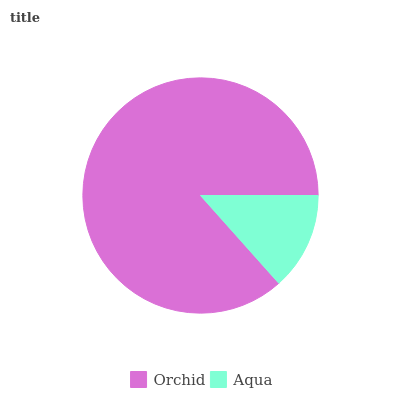Is Aqua the minimum?
Answer yes or no. Yes. Is Orchid the maximum?
Answer yes or no. Yes. Is Aqua the maximum?
Answer yes or no. No. Is Orchid greater than Aqua?
Answer yes or no. Yes. Is Aqua less than Orchid?
Answer yes or no. Yes. Is Aqua greater than Orchid?
Answer yes or no. No. Is Orchid less than Aqua?
Answer yes or no. No. Is Orchid the high median?
Answer yes or no. Yes. Is Aqua the low median?
Answer yes or no. Yes. Is Aqua the high median?
Answer yes or no. No. Is Orchid the low median?
Answer yes or no. No. 